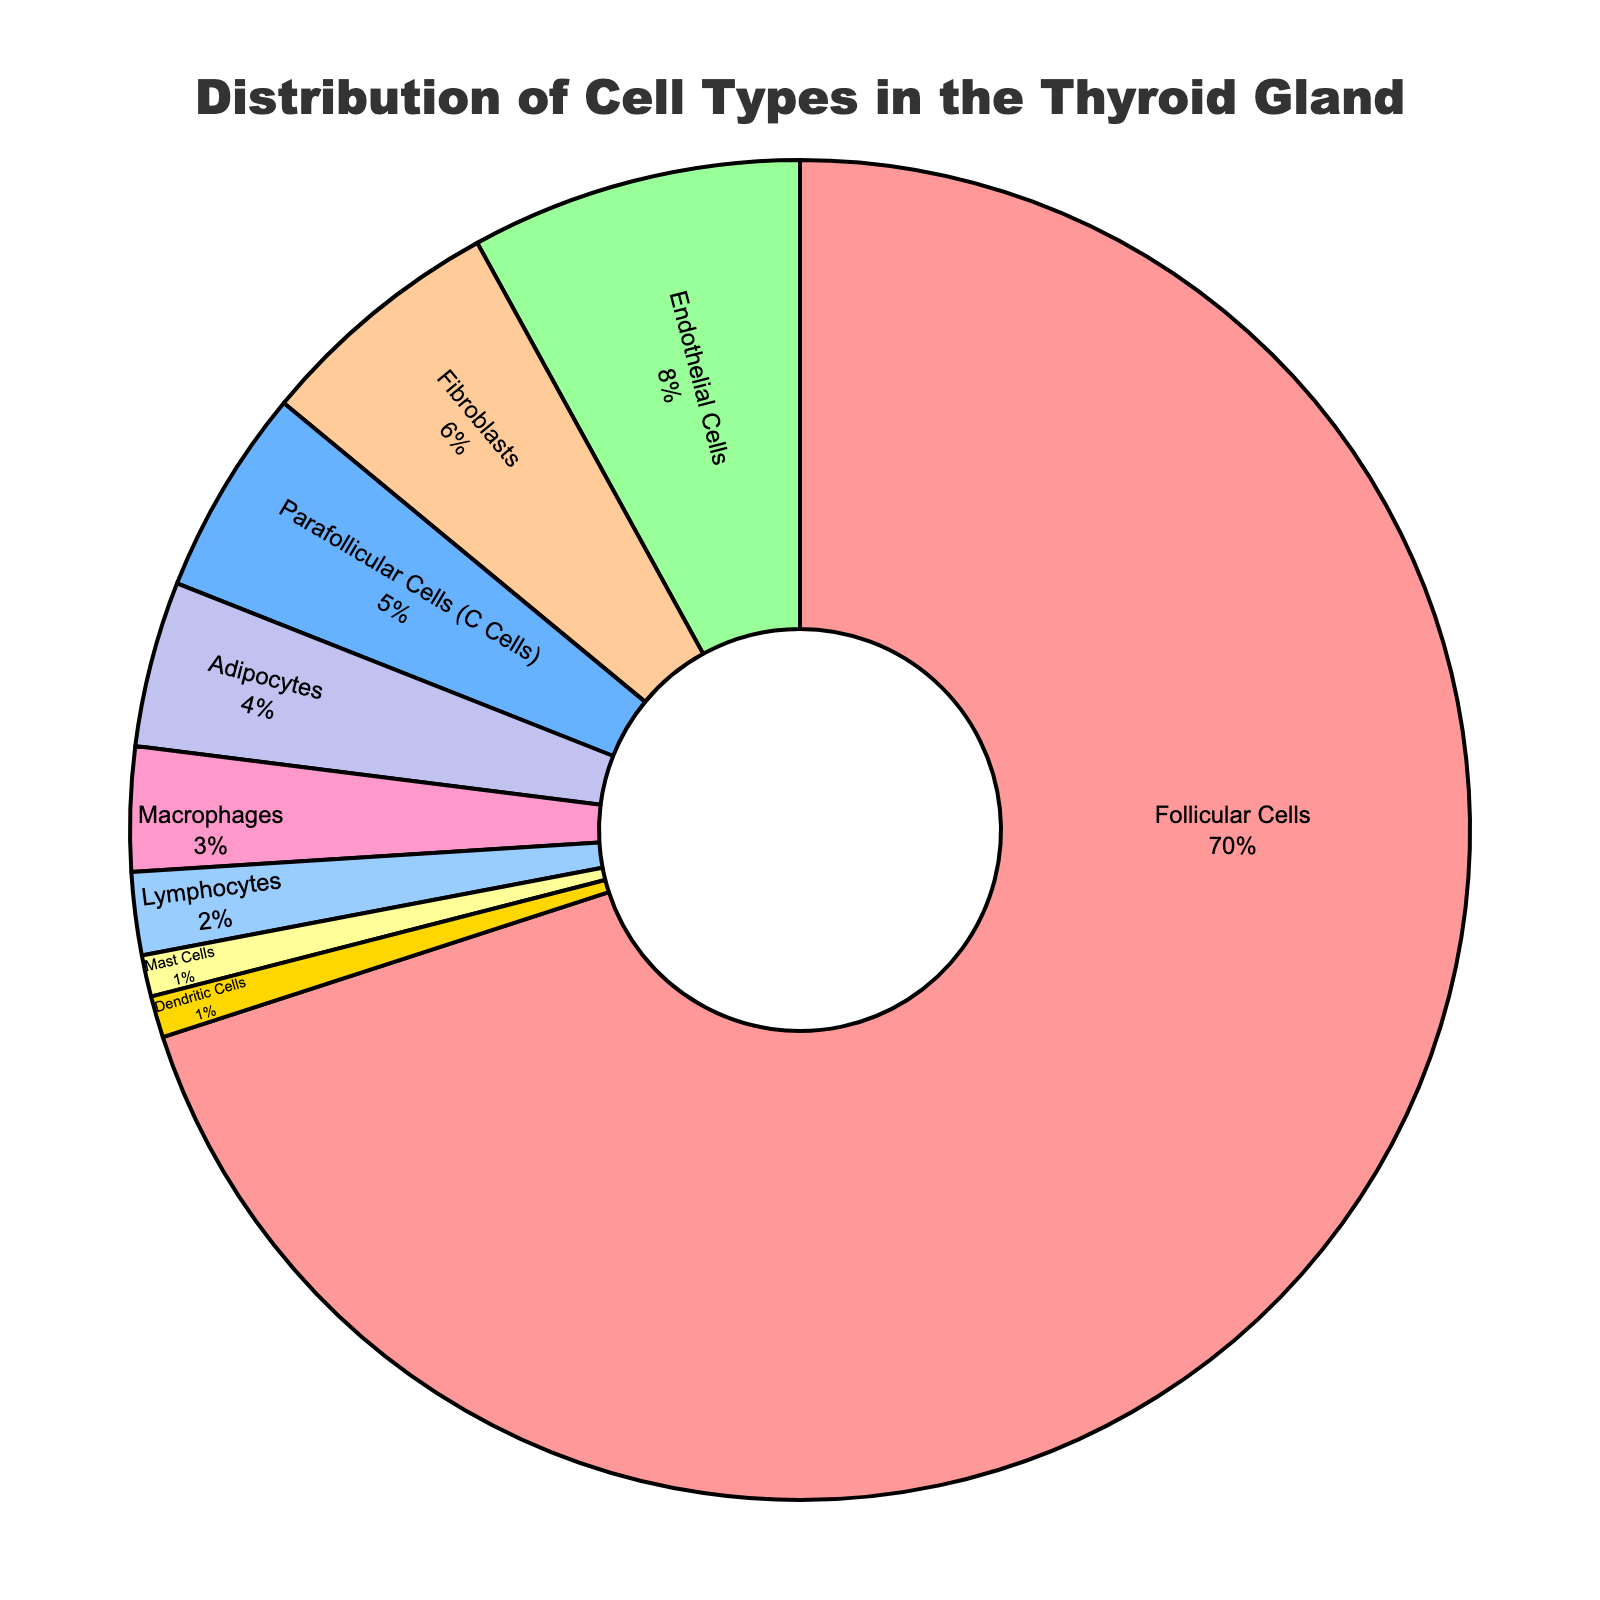What is the percentage of Follicular Cells? Follicular Cells have the largest section in the pie chart, and the percentage displayed next to their label is 70%.
Answer: 70% Which cell type has the smallest percentage, and what is its value? Mast Cells and Dendritic Cells are both the smallest segments in the pie chart, each labeled with a 1% value.
Answer: Mast Cells and Dendritic Cells, 1% What is the combined percentage of Macrophages, Lymphocytes, and Mast Cells? By adding the percentages of Macrophages (3%), Lymphocytes (2%), and Mast Cells (1%), we get 3% + 2% + 1% = 6%.
Answer: 6% Which cell type is represented by a blue section? The Parafollicular Cells (C Cells) are represented by a blue section in the pie chart.
Answer: Parafollicular Cells (C Cells) How does the percentage of Fibroblasts compare to that of Adipocytes? Fibroblasts account for 6% of the pie chart, whereas Adipocytes account for 4%. Hence, Fibroblasts' percentage is 2% larger than Adipocytes'.
Answer: 2% larger What is the percentage difference between Follicular Cells and Endothelial Cells? Follicular Cells make up 70% of the pie chart, while Endothelial Cells make up 8%. The difference in their percentages is 70% - 8% = 62%.
Answer: 62% Are there any cell types with equal percentages in the pie chart? Yes, Mast Cells and Dendritic Cells both have equal percentages of 1% as shown in the pie chart.
Answer: Yes, Mast Cells and Dendritic Cells If you combine the percentages of Parafollicular Cells (C Cells) and Adipocytes, is this greater than the percentage of Endothelial Cells? The percentage of Parafollicular Cells (C Cells) is 5%, and Adipocytes is 4%. Combined, they make 5% + 4% = 9%, which is greater than the percentage of Endothelial Cells (8%).
Answer: Yes What percentage of the thyroid gland is made up of cell types other than Follicular Cells? Follicular Cells make up 70%, so the remaining percentage is 100% - 70% = 30%.
Answer: 30% 